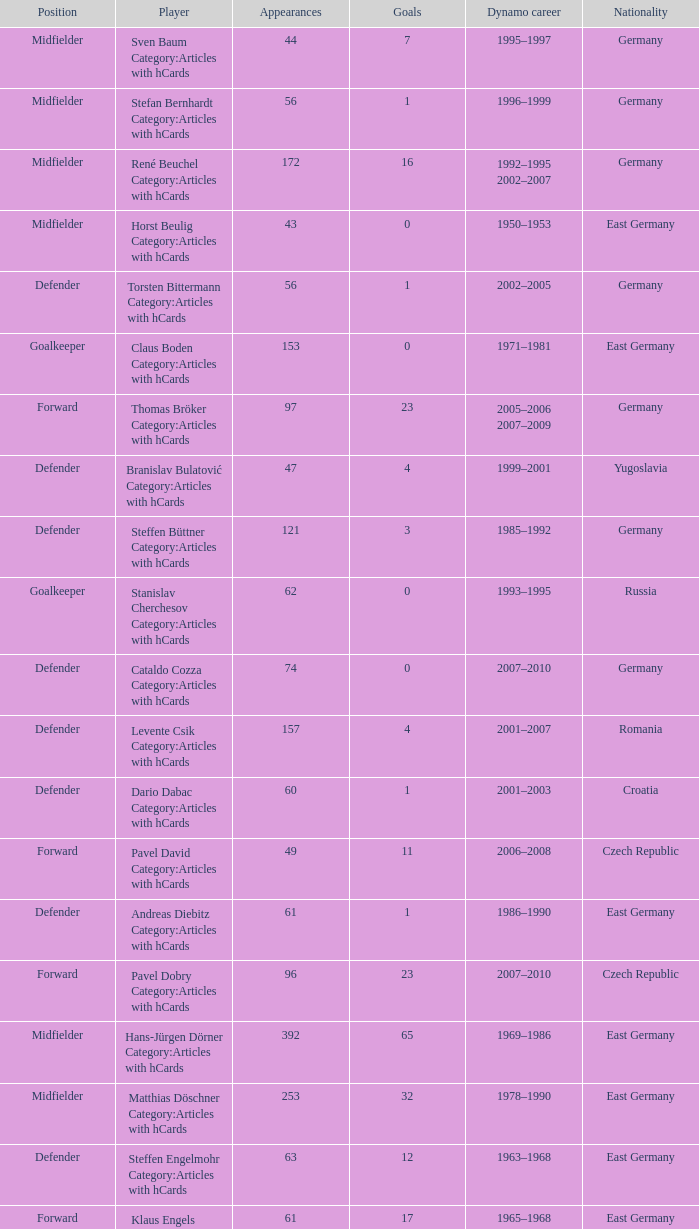What was the position of the player with 57 goals? Forward. 